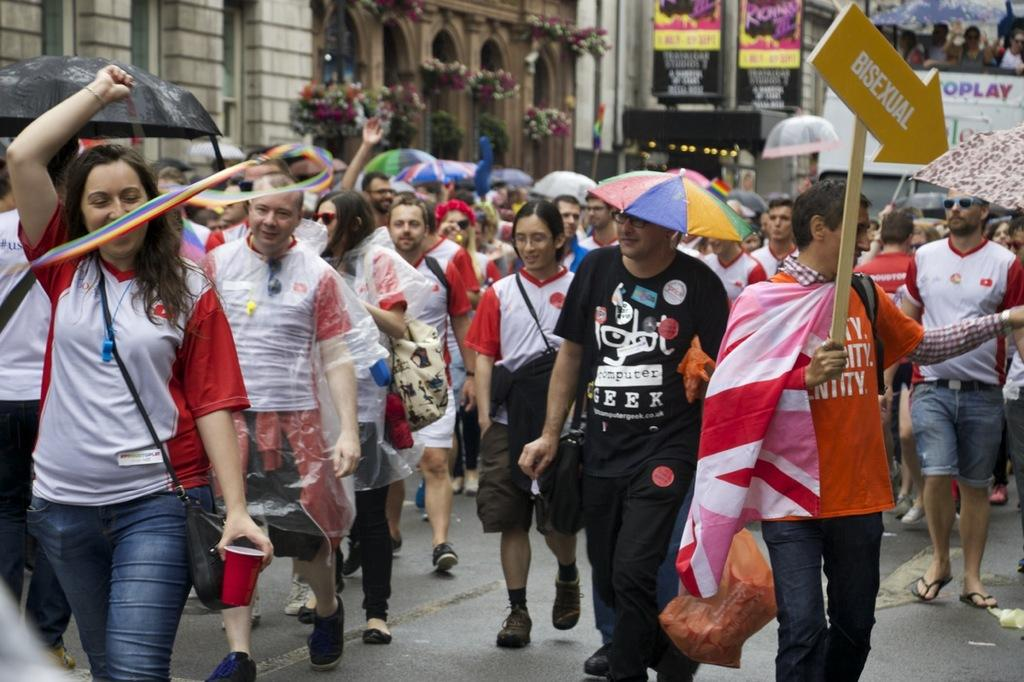What can be observed about the attire of the persons in the image? There are persons in different color dresses in the image. What are some of the persons using to protect themselves from the elements? Some of the persons are holding umbrellas. Where does the scene take place? The scene takes place on a road. What can be seen in the background of the image? There are hoardings, pot plants, and buildings in the background of the image. What type of cream is being served at the society meeting in the image? There is no society meeting or cream present in the image. What kind of oatmeal is being prepared by the persons in the image? There is no oatmeal or preparation activity visible in the image. 